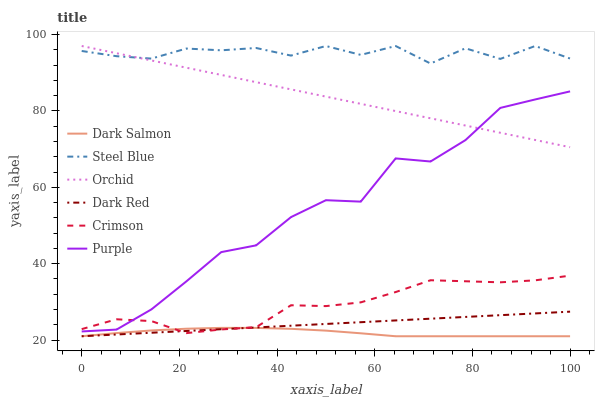Does Dark Salmon have the minimum area under the curve?
Answer yes or no. Yes. Does Steel Blue have the maximum area under the curve?
Answer yes or no. Yes. Does Dark Red have the minimum area under the curve?
Answer yes or no. No. Does Dark Red have the maximum area under the curve?
Answer yes or no. No. Is Dark Red the smoothest?
Answer yes or no. Yes. Is Purple the roughest?
Answer yes or no. Yes. Is Dark Salmon the smoothest?
Answer yes or no. No. Is Dark Salmon the roughest?
Answer yes or no. No. Does Steel Blue have the lowest value?
Answer yes or no. No. Does Orchid have the highest value?
Answer yes or no. Yes. Does Dark Red have the highest value?
Answer yes or no. No. Is Purple less than Steel Blue?
Answer yes or no. Yes. Is Orchid greater than Crimson?
Answer yes or no. Yes. Does Crimson intersect Dark Red?
Answer yes or no. Yes. Is Crimson less than Dark Red?
Answer yes or no. No. Is Crimson greater than Dark Red?
Answer yes or no. No. Does Purple intersect Steel Blue?
Answer yes or no. No. 